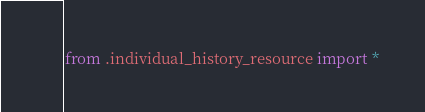<code> <loc_0><loc_0><loc_500><loc_500><_Python_>from .individual_history_resource import *
</code> 